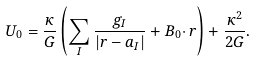Convert formula to latex. <formula><loc_0><loc_0><loc_500><loc_500>U _ { 0 } = \frac { \kappa } { G } \left ( \sum _ { I } \frac { g _ { I } } { | { r } - { a } _ { I } | } + { B } _ { 0 } { \cdot \, r } \right ) + \frac { \kappa ^ { 2 } } { 2 G } .</formula> 